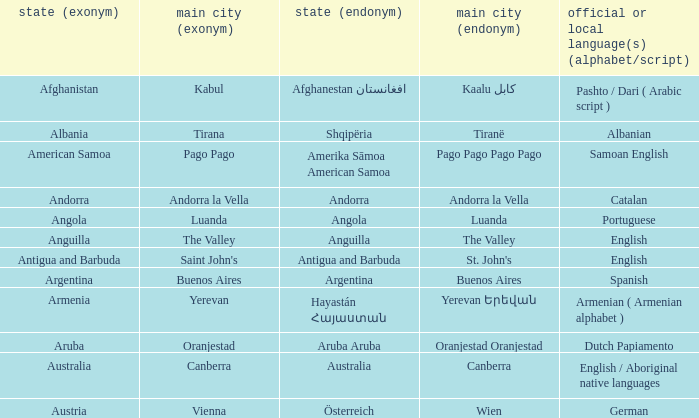What is the English name given to the city of St. John's? Saint John's. 